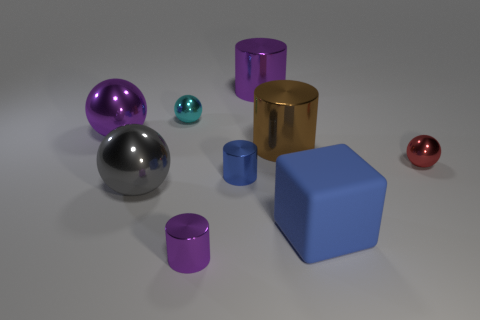There is another small sphere that is the same material as the small red ball; what color is it?
Provide a short and direct response. Cyan. What is the size of the object that is both right of the brown object and to the left of the red metallic object?
Offer a very short reply. Large. Are there fewer red objects on the left side of the big purple metal sphere than red metal things right of the big brown metallic cylinder?
Keep it short and to the point. Yes. Are the purple object in front of the big purple metallic sphere and the purple cylinder behind the large matte thing made of the same material?
Make the answer very short. Yes. There is a tiny thing that is the same color as the big block; what is its material?
Your answer should be very brief. Metal. What shape is the thing that is both in front of the gray object and left of the blue rubber cube?
Your response must be concise. Cylinder. There is a small cylinder that is to the right of the purple shiny thing that is in front of the tiny red shiny ball; what is its material?
Your response must be concise. Metal. Is the number of brown metal things greater than the number of large objects?
Ensure brevity in your answer.  No. There is a purple ball that is the same size as the brown cylinder; what is its material?
Offer a terse response. Metal. Are the large cube and the large purple sphere made of the same material?
Your response must be concise. No. 